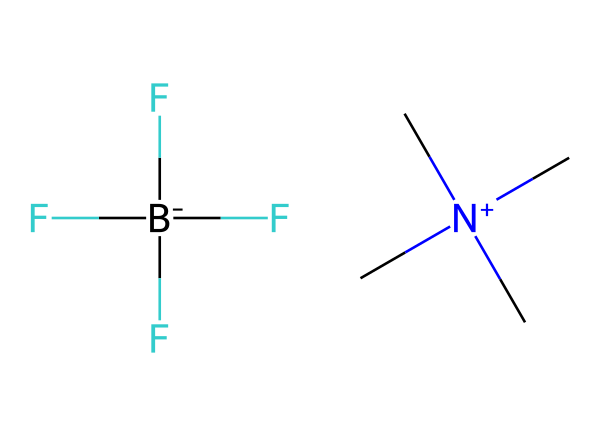What is the cation in this ionic liquid? The structure shows a quaternary ammonium ion, indicated by the nitrogen atom bonded to three methyl groups and a positive charge.
Answer: C[N+](C)(C)C What is the anion in this ionic liquid? The structure displays a perfluorinated boron anion, represented by the fluorine atoms bonded to the boron atom and carrying a negative charge.
Answer: F[B-](F)(F)F How many carbon atoms are present in the cation? Analyzing the quaternary ammonium structure, there are four carbon atoms connected to the nitrogen (three from the methyl groups and one as part of the nitrogen's structure).
Answer: 4 How does the presence of fluorine affect the properties of this ionic liquid? Fluorine atoms increase the hydrophobic character and thermal stability of the ionic liquid, due to their electronegativity and low polarizability.
Answer: Increased stability Why are ionic liquids considered eco-friendly for sterilization? Ionic liquids have low volatility, meaning they do not evaporate quickly, reducing air pollution and making them safer for the environment during use.
Answer: Low volatility What is the charge on the anion in this ionic liquid? The structure indicates the anion has a single negative charge, denoted by the brackets and negative sign attached to the boron atom.
Answer: -1 